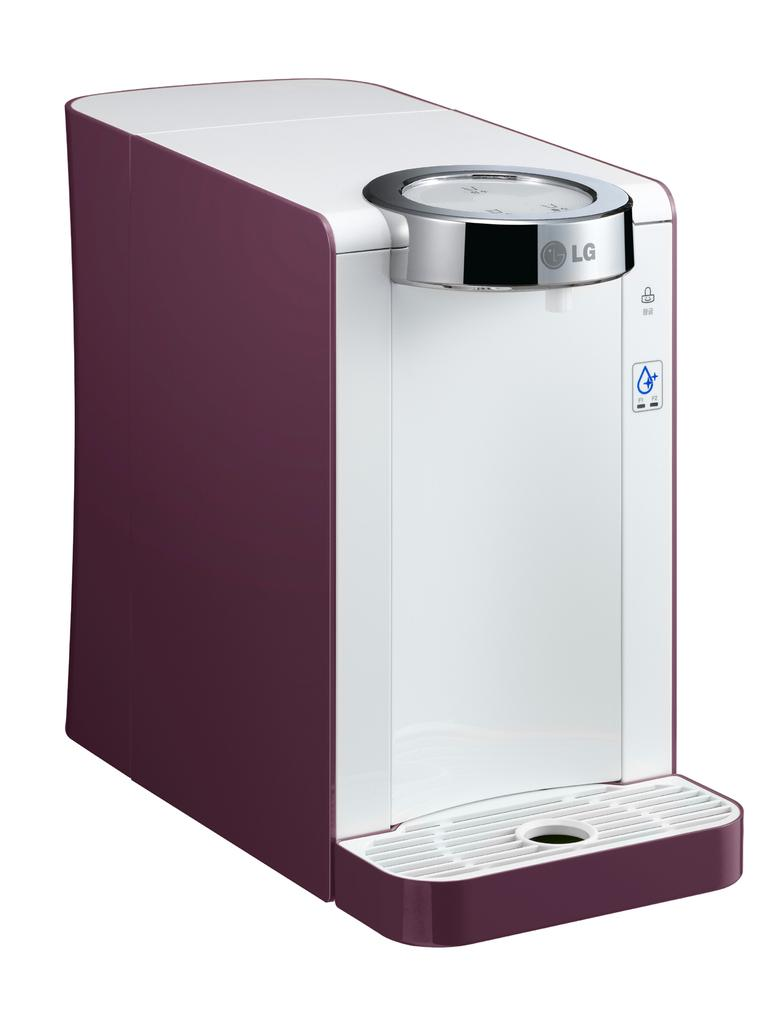<image>
Describe the image concisely. The coffee maker shown is made by the company LG. 